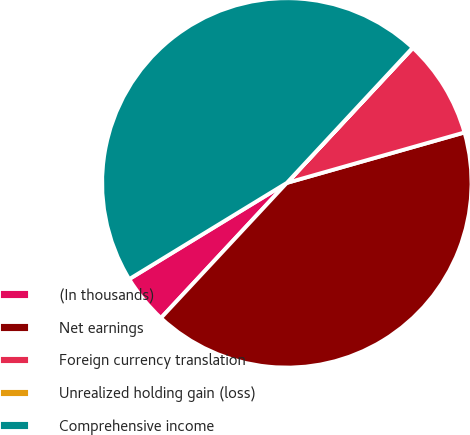Convert chart to OTSL. <chart><loc_0><loc_0><loc_500><loc_500><pie_chart><fcel>(In thousands)<fcel>Net earnings<fcel>Foreign currency translation<fcel>Unrealized holding gain (loss)<fcel>Comprehensive income<nl><fcel>4.34%<fcel>41.34%<fcel>8.64%<fcel>0.03%<fcel>45.65%<nl></chart> 